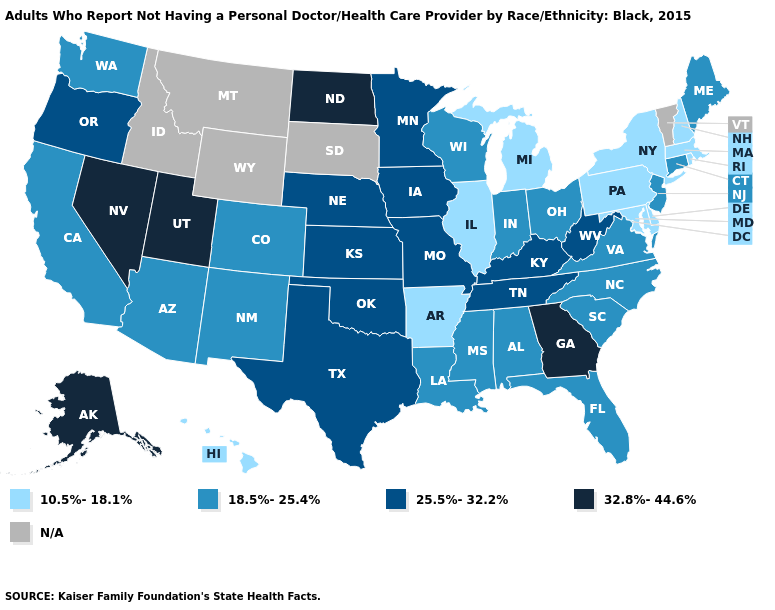Does Nevada have the lowest value in the USA?
Give a very brief answer. No. Among the states that border Kansas , which have the highest value?
Answer briefly. Missouri, Nebraska, Oklahoma. What is the value of Michigan?
Be succinct. 10.5%-18.1%. What is the lowest value in the USA?
Answer briefly. 10.5%-18.1%. Which states have the lowest value in the Northeast?
Answer briefly. Massachusetts, New Hampshire, New York, Pennsylvania, Rhode Island. Name the states that have a value in the range 18.5%-25.4%?
Write a very short answer. Alabama, Arizona, California, Colorado, Connecticut, Florida, Indiana, Louisiana, Maine, Mississippi, New Jersey, New Mexico, North Carolina, Ohio, South Carolina, Virginia, Washington, Wisconsin. Does North Carolina have the lowest value in the South?
Quick response, please. No. What is the value of Nebraska?
Concise answer only. 25.5%-32.2%. Among the states that border Alabama , which have the highest value?
Concise answer only. Georgia. Name the states that have a value in the range 10.5%-18.1%?
Quick response, please. Arkansas, Delaware, Hawaii, Illinois, Maryland, Massachusetts, Michigan, New Hampshire, New York, Pennsylvania, Rhode Island. What is the value of Connecticut?
Give a very brief answer. 18.5%-25.4%. What is the highest value in states that border Wyoming?
Be succinct. 32.8%-44.6%. Which states have the lowest value in the USA?
Keep it brief. Arkansas, Delaware, Hawaii, Illinois, Maryland, Massachusetts, Michigan, New Hampshire, New York, Pennsylvania, Rhode Island. Which states have the lowest value in the USA?
Give a very brief answer. Arkansas, Delaware, Hawaii, Illinois, Maryland, Massachusetts, Michigan, New Hampshire, New York, Pennsylvania, Rhode Island. 